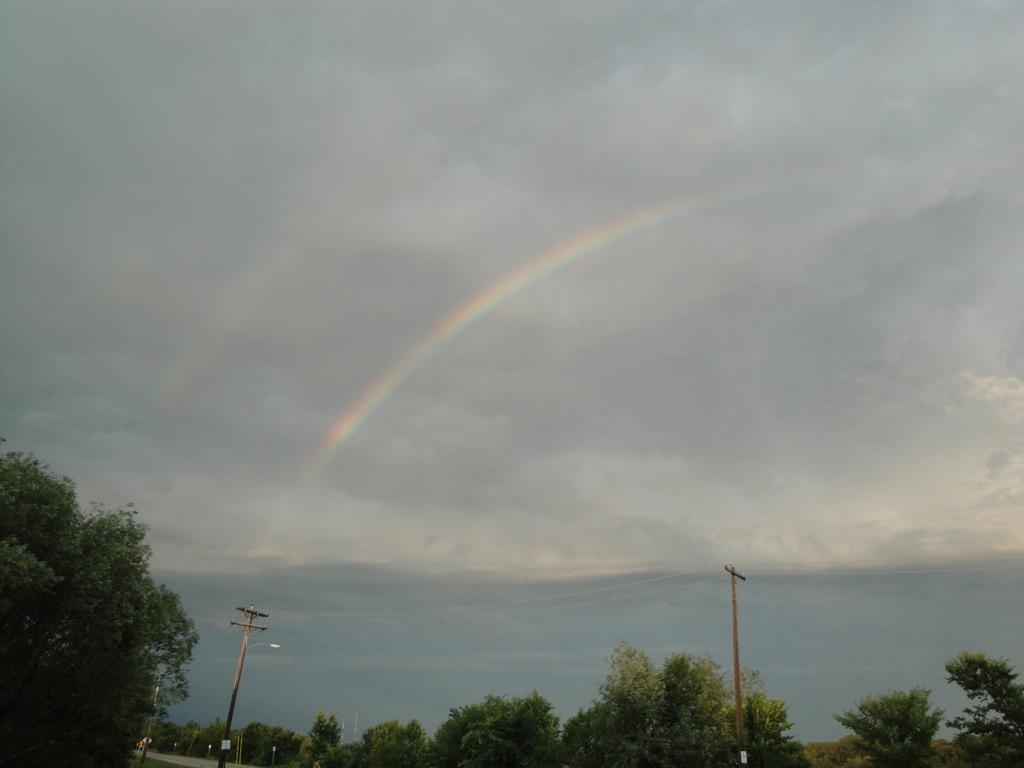What type of natural elements can be seen in the image? There are many trees in the image. What man-made structures are present in the image? There are electrical poles in the image. What natural phenomenon can be observed in the sky in the image? There is a rainbow in the sky in the image. How many eggs are present on the electrical poles in the image? There are no eggs present on the electrical poles in the image. 